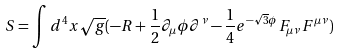<formula> <loc_0><loc_0><loc_500><loc_500>S = \int d ^ { 4 } x \sqrt { g } ( - R + \frac { 1 } { 2 } \partial _ { \mu } \phi \partial ^ { \nu } - \frac { 1 } { 4 } e ^ { - \sqrt { 3 } \phi } F _ { \mu \nu } F ^ { \mu \nu } )</formula> 